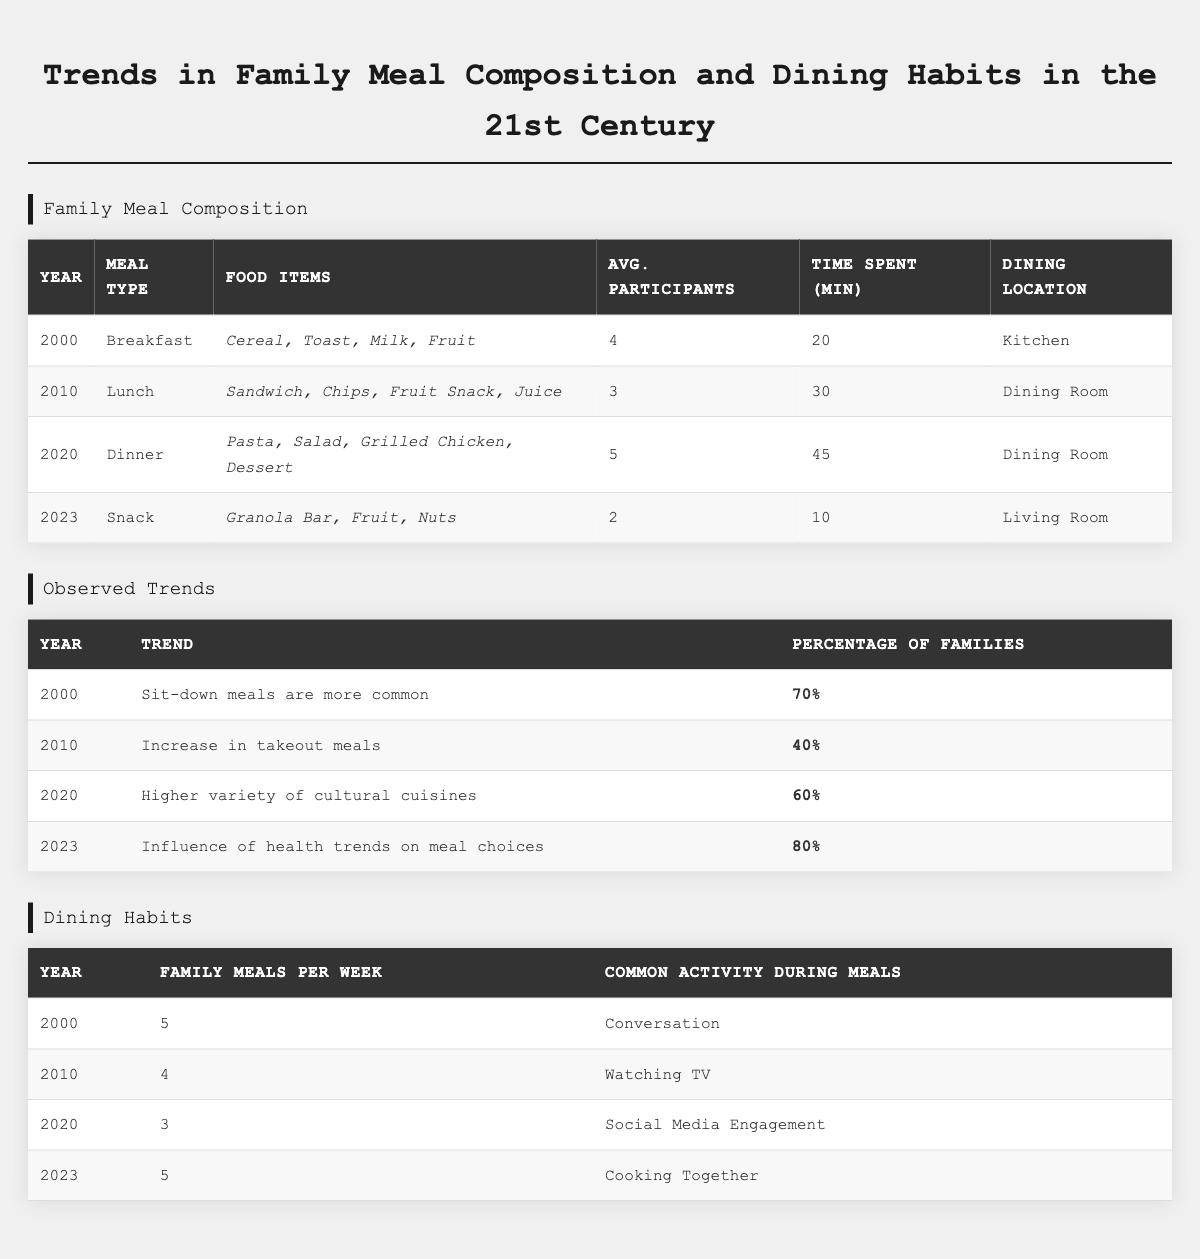What meal type had the highest average participants in the year 2020? In the year 2020, dinner had the highest average participants listed in the table, with 5 participants.
Answer: Dinner How many food items were typically included in the breakfast meal in 2000? The breakfast meal in 2000 included 4 food items: Cereal, Toast, Milk, and Fruit.
Answer: 4 food items What percentage of families reported the influence of health trends on meal choices in 2023? In 2023, the table states that 80% of families reported the influence of health trends on their meal choices.
Answer: 80% Did family meals per week decline from 2000 to 2020? Yes, family meals per week decreased from 5 in 2000 to 3 in 2020, indicating a decline.
Answer: Yes What was the common activity during meals in 2010? In 2010, the common activity during meals was watching TV, according to the table.
Answer: Watching TV How many families reported sit-down meals being more common in 2000 compared to the trend in 2010? In 2000, 70% of families reported sit-down meals being common, which is higher than the 40% of families in 2010 who reported an increase in takeout meals, indicating a change in preference.
Answer: 30% What was the average time spent for lunch in 2010? The table indicates that the average time spent for lunch in 2010 was 30 minutes.
Answer: 30 minutes Which meal type had the least number of average participants, and what year was it? In 2023, the snack meal type had the least number of average participants, with only 2 participants.
Answer: Snack in 2023 If the average time spent on dinner is compared to breakfast, how much longer is dinner? The average time spent on dinner (45 minutes) minus the average time spent on breakfast (20 minutes) equals a difference of 25 minutes, showing that dinner took 25 minutes longer than breakfast.
Answer: 25 minutes Was there an increase in the frequency of family meals per week from 2020 to 2023? Yes, the frequency increased from 3 meals per week in 2020 to 5 meals per week in 2023, indicating a positive trend.
Answer: Yes 